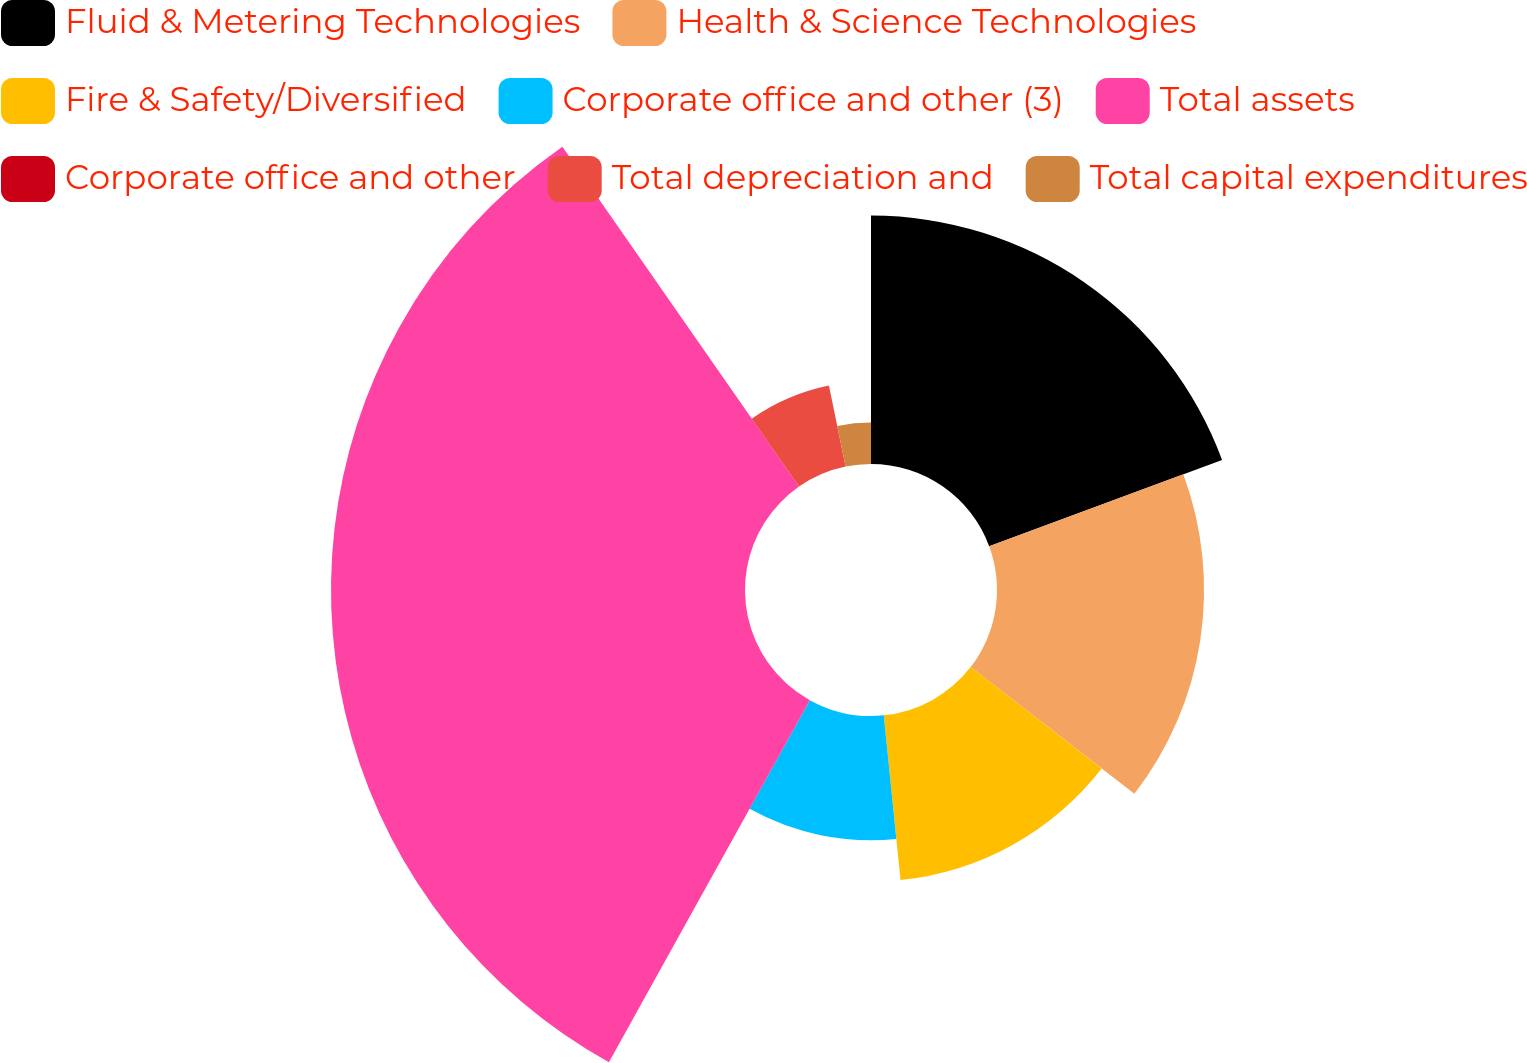Convert chart to OTSL. <chart><loc_0><loc_0><loc_500><loc_500><pie_chart><fcel>Fluid & Metering Technologies<fcel>Health & Science Technologies<fcel>Fire & Safety/Diversified<fcel>Corporate office and other (3)<fcel>Total assets<fcel>Corporate office and other<fcel>Total depreciation and<fcel>Total capital expenditures<nl><fcel>19.35%<fcel>16.13%<fcel>12.9%<fcel>9.68%<fcel>32.25%<fcel>0.0%<fcel>6.45%<fcel>3.23%<nl></chart> 